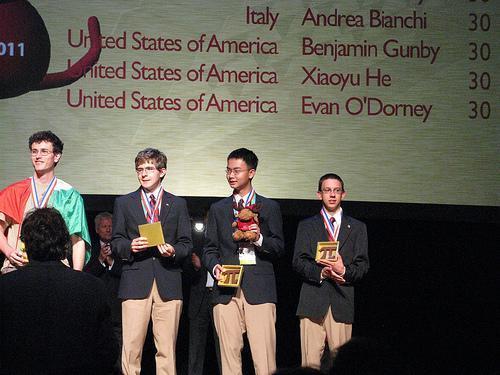How many people are holding tv?
Give a very brief answer. 0. 